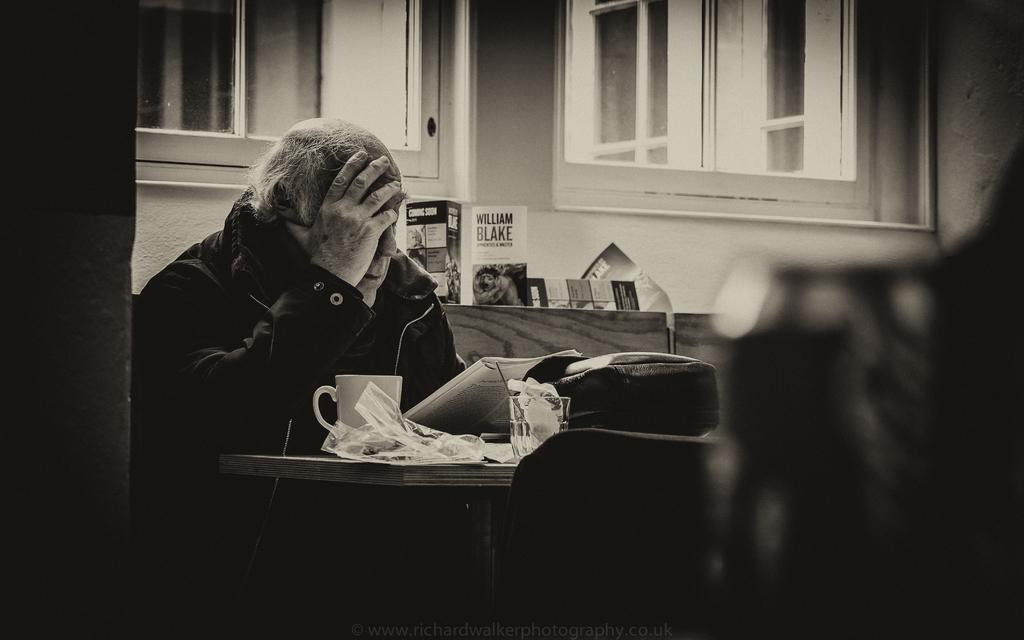What is the color scheme of the image? The image is black and white. What is the person in the image doing? The person is sitting in the image. What items can be seen on the table? There is a book, a glass, and a cup on the table. Are there any other objects on the table? Yes, there are other objects on the table. What can be seen in the background of the image? There are windows and a wall in the background. What type of bone is visible on the table in the image? There is no bone visible on the table in the image. How many men are present in the image? There is no mention of men in the image; only a person sitting is described. 